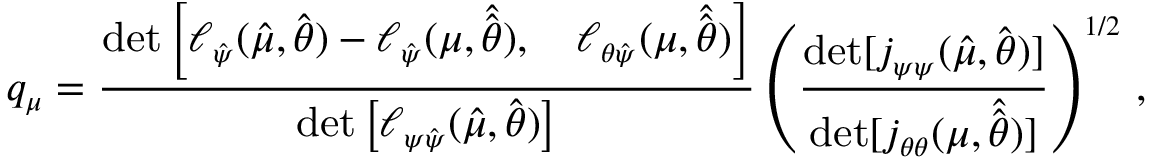Convert formula to latex. <formula><loc_0><loc_0><loc_500><loc_500>q _ { \mu } = \frac { d e t \left [ \ell _ { \hat { \psi } } ( \hat { \mu } , \hat { \theta } ) - \ell _ { \hat { \psi } } ( \mu , \hat { \hat { \theta } } ) , \quad \ell _ { \theta \hat { \psi } } ( \mu , \hat { \hat { \theta } } ) \right ] } { d e t \left [ \ell _ { \psi \hat { \psi } } ( \hat { \mu } , \hat { \theta } ) \right ] } \left ( \frac { d e t [ j _ { \psi \psi } ( \hat { \mu } , \hat { \theta } ) ] } { d e t [ j _ { \theta \theta } ( \mu , \hat { \hat { \theta } } ) ] } \right ) ^ { 1 / 2 } \, ,</formula> 